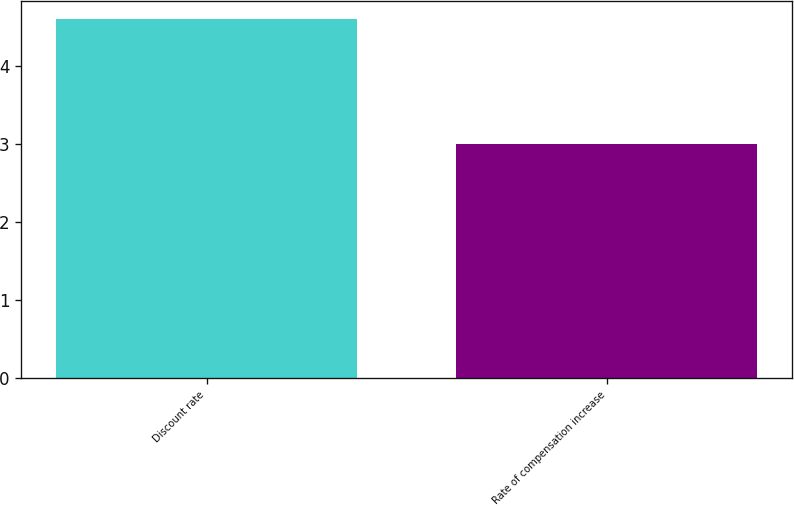<chart> <loc_0><loc_0><loc_500><loc_500><bar_chart><fcel>Discount rate<fcel>Rate of compensation increase<nl><fcel>4.6<fcel>3<nl></chart> 